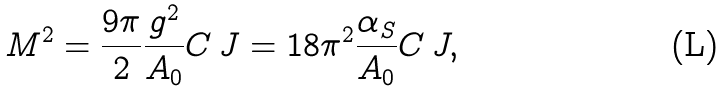Convert formula to latex. <formula><loc_0><loc_0><loc_500><loc_500>M ^ { 2 } = \frac { 9 \pi } { 2 } \frac { g ^ { 2 } } { A _ { 0 } } C \, J = 1 8 \pi ^ { 2 } \frac { \alpha _ { S } } { A _ { 0 } } C \, J ,</formula> 